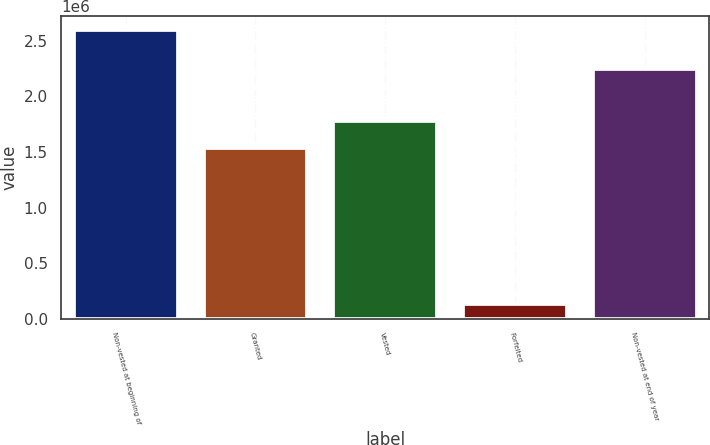<chart> <loc_0><loc_0><loc_500><loc_500><bar_chart><fcel>Non-vested at beginning of<fcel>Granted<fcel>Vested<fcel>Forfeited<fcel>Non-vested at end of year<nl><fcel>2.59457e+06<fcel>1.53184e+06<fcel>1.77772e+06<fcel>135785<fcel>2.24403e+06<nl></chart> 